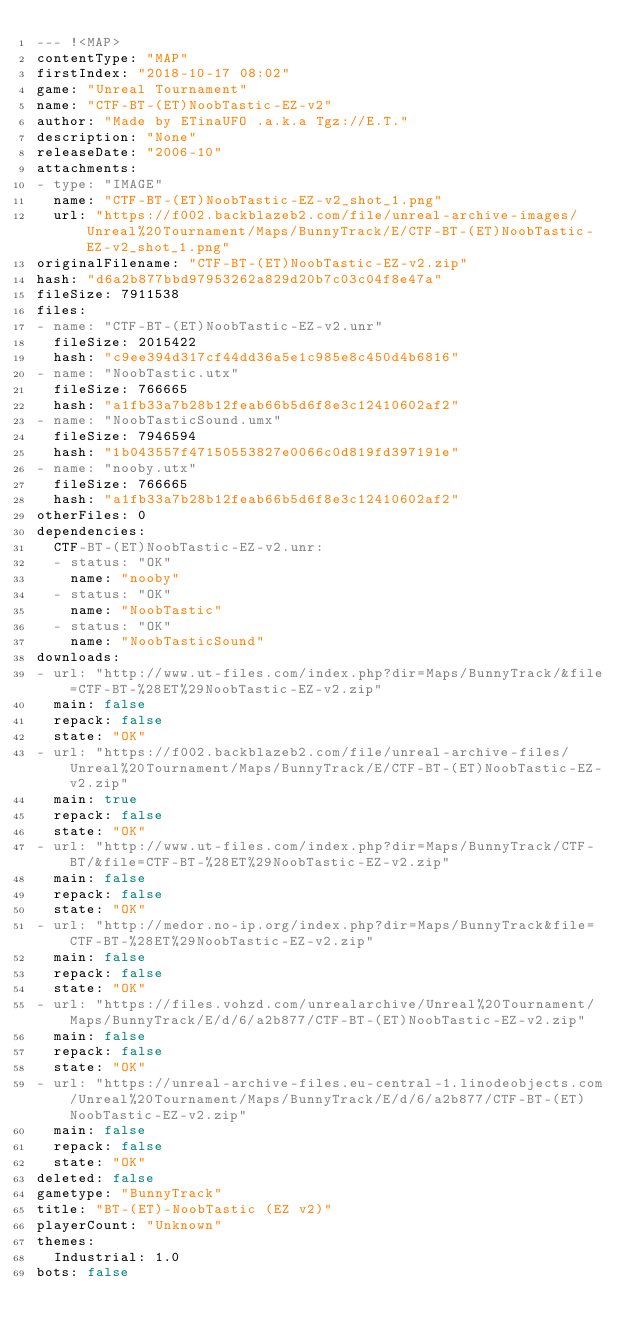Convert code to text. <code><loc_0><loc_0><loc_500><loc_500><_YAML_>--- !<MAP>
contentType: "MAP"
firstIndex: "2018-10-17 08:02"
game: "Unreal Tournament"
name: "CTF-BT-(ET)NoobTastic-EZ-v2"
author: "Made by ETinaUFO .a.k.a Tgz://E.T."
description: "None"
releaseDate: "2006-10"
attachments:
- type: "IMAGE"
  name: "CTF-BT-(ET)NoobTastic-EZ-v2_shot_1.png"
  url: "https://f002.backblazeb2.com/file/unreal-archive-images/Unreal%20Tournament/Maps/BunnyTrack/E/CTF-BT-(ET)NoobTastic-EZ-v2_shot_1.png"
originalFilename: "CTF-BT-(ET)NoobTastic-EZ-v2.zip"
hash: "d6a2b877bbd97953262a829d20b7c03c04f8e47a"
fileSize: 7911538
files:
- name: "CTF-BT-(ET)NoobTastic-EZ-v2.unr"
  fileSize: 2015422
  hash: "c9ee394d317cf44dd36a5e1c985e8c450d4b6816"
- name: "NoobTastic.utx"
  fileSize: 766665
  hash: "a1fb33a7b28b12feab66b5d6f8e3c12410602af2"
- name: "NoobTasticSound.umx"
  fileSize: 7946594
  hash: "1b043557f47150553827e0066c0d819fd397191e"
- name: "nooby.utx"
  fileSize: 766665
  hash: "a1fb33a7b28b12feab66b5d6f8e3c12410602af2"
otherFiles: 0
dependencies:
  CTF-BT-(ET)NoobTastic-EZ-v2.unr:
  - status: "OK"
    name: "nooby"
  - status: "OK"
    name: "NoobTastic"
  - status: "OK"
    name: "NoobTasticSound"
downloads:
- url: "http://www.ut-files.com/index.php?dir=Maps/BunnyTrack/&file=CTF-BT-%28ET%29NoobTastic-EZ-v2.zip"
  main: false
  repack: false
  state: "OK"
- url: "https://f002.backblazeb2.com/file/unreal-archive-files/Unreal%20Tournament/Maps/BunnyTrack/E/CTF-BT-(ET)NoobTastic-EZ-v2.zip"
  main: true
  repack: false
  state: "OK"
- url: "http://www.ut-files.com/index.php?dir=Maps/BunnyTrack/CTF-BT/&file=CTF-BT-%28ET%29NoobTastic-EZ-v2.zip"
  main: false
  repack: false
  state: "OK"
- url: "http://medor.no-ip.org/index.php?dir=Maps/BunnyTrack&file=CTF-BT-%28ET%29NoobTastic-EZ-v2.zip"
  main: false
  repack: false
  state: "OK"
- url: "https://files.vohzd.com/unrealarchive/Unreal%20Tournament/Maps/BunnyTrack/E/d/6/a2b877/CTF-BT-(ET)NoobTastic-EZ-v2.zip"
  main: false
  repack: false
  state: "OK"
- url: "https://unreal-archive-files.eu-central-1.linodeobjects.com/Unreal%20Tournament/Maps/BunnyTrack/E/d/6/a2b877/CTF-BT-(ET)NoobTastic-EZ-v2.zip"
  main: false
  repack: false
  state: "OK"
deleted: false
gametype: "BunnyTrack"
title: "BT-(ET)-NoobTastic (EZ v2)"
playerCount: "Unknown"
themes:
  Industrial: 1.0
bots: false
</code> 